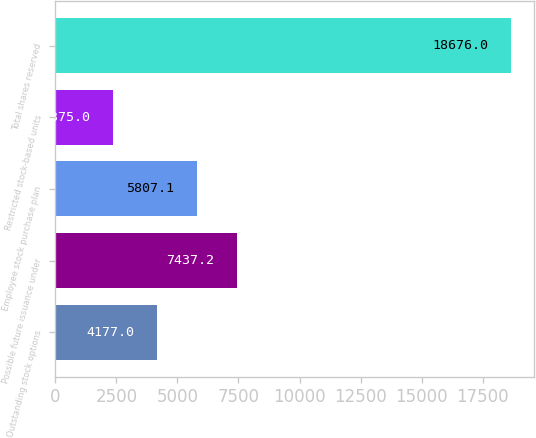Convert chart. <chart><loc_0><loc_0><loc_500><loc_500><bar_chart><fcel>Outstanding stock options<fcel>Possible future issuance under<fcel>Employee stock purchase plan<fcel>Restricted stock-based units<fcel>Total shares reserved<nl><fcel>4177<fcel>7437.2<fcel>5807.1<fcel>2375<fcel>18676<nl></chart> 